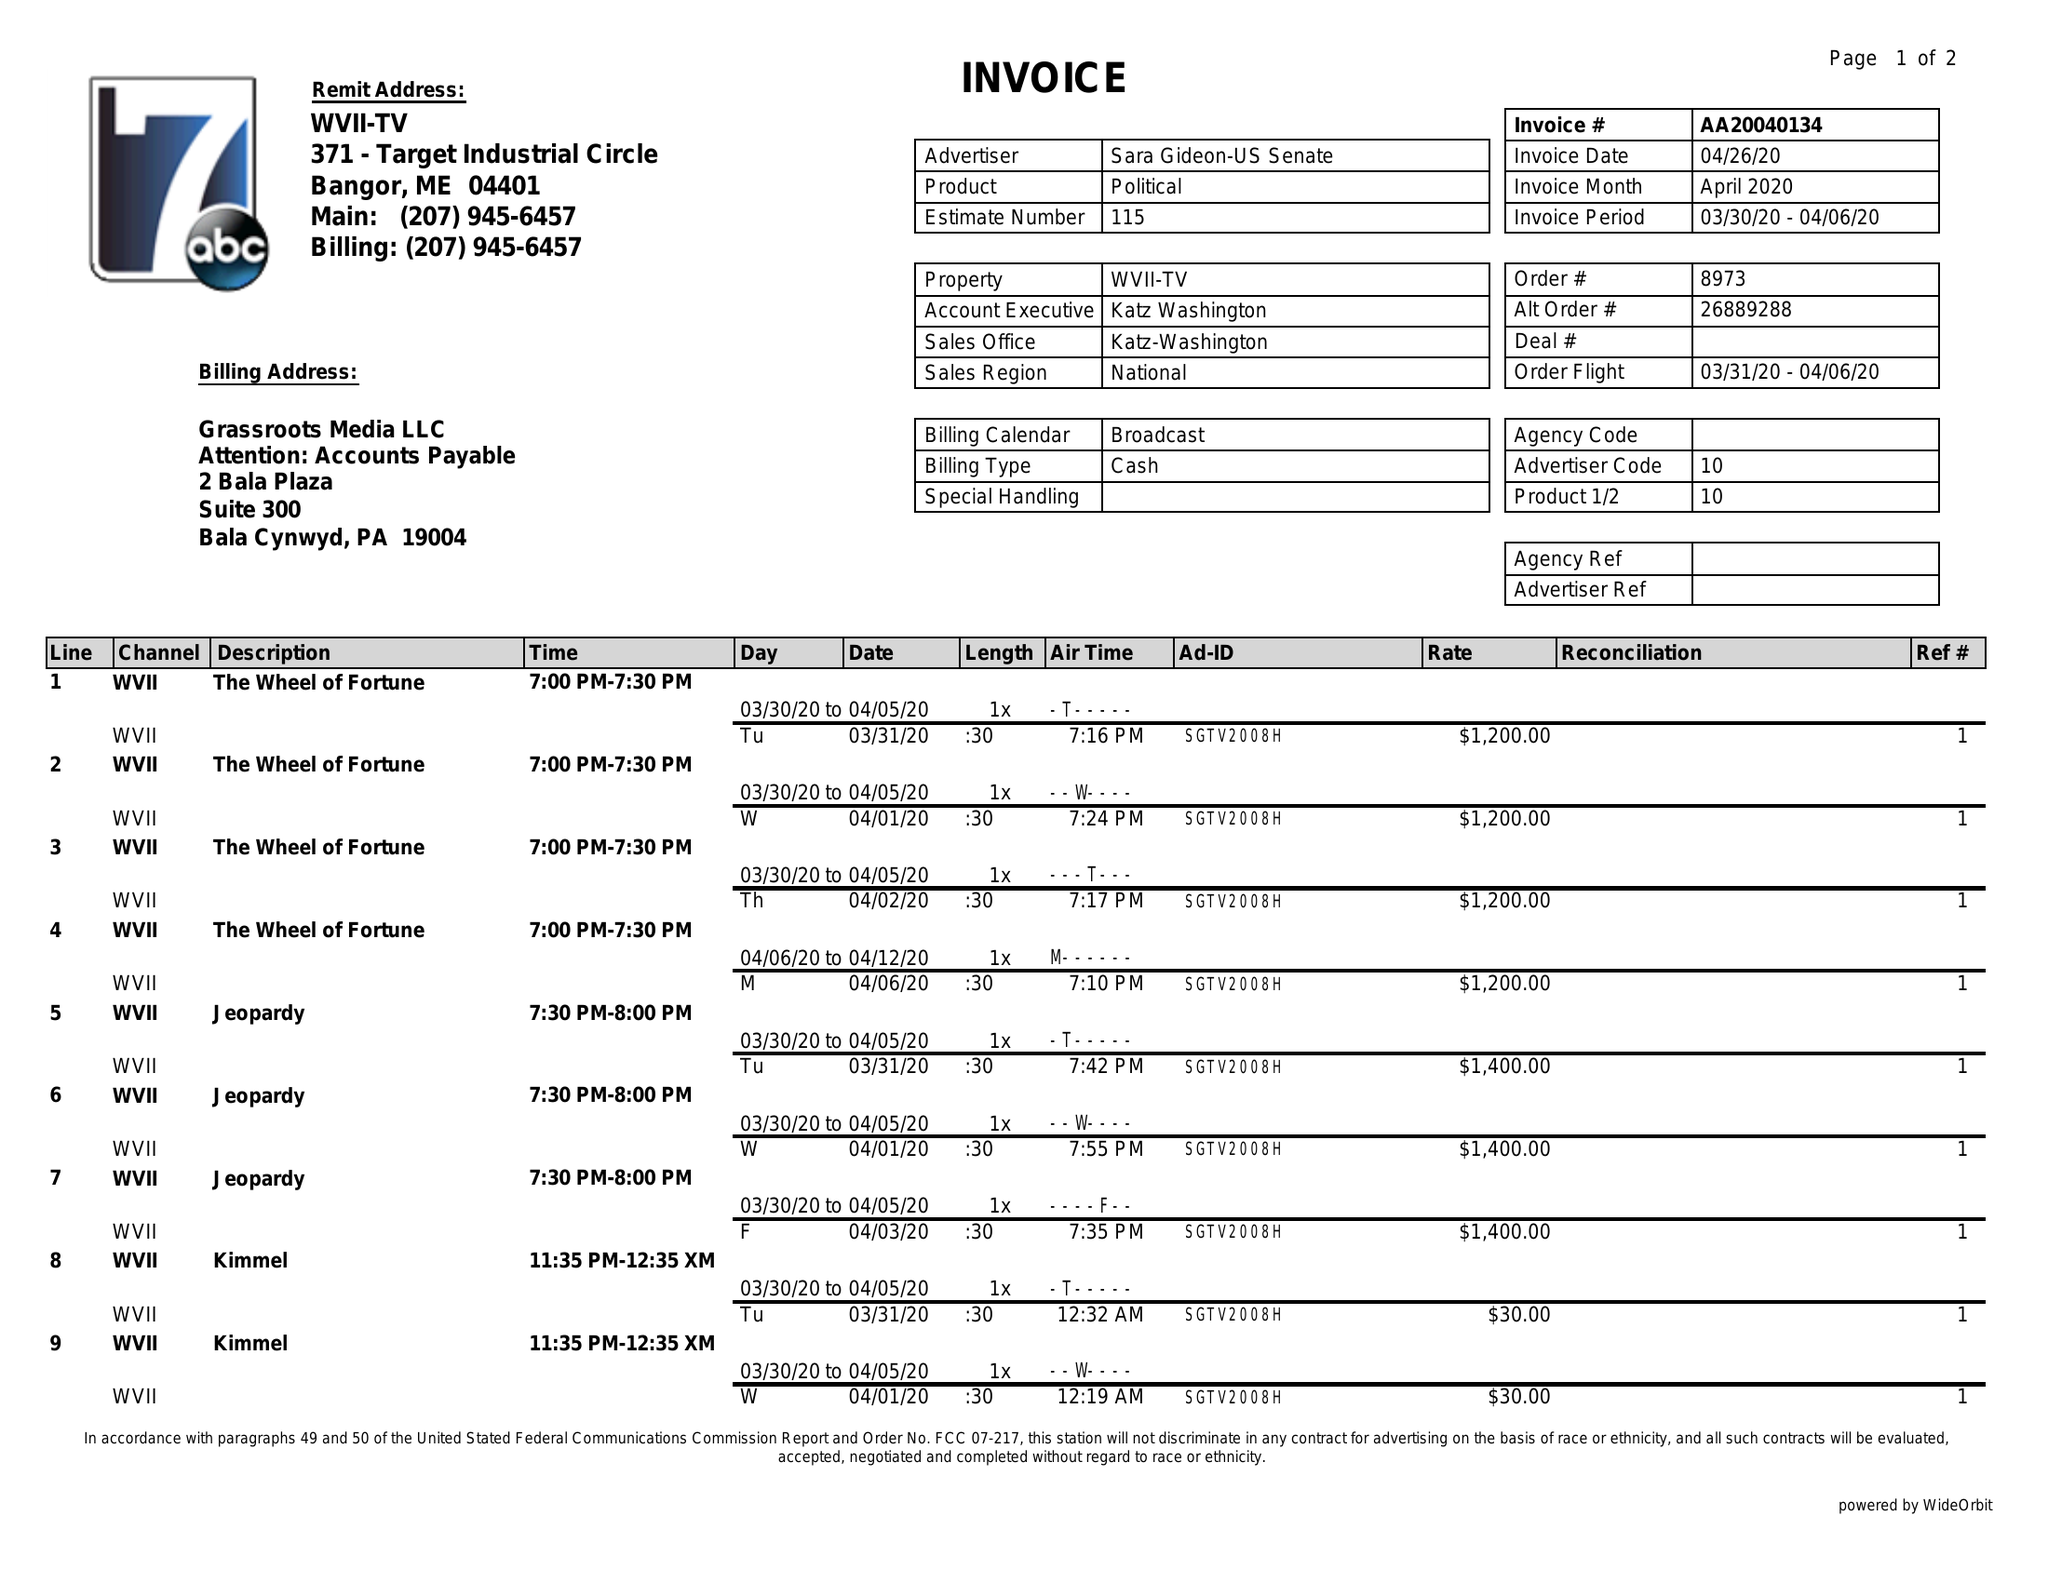What is the value for the flight_from?
Answer the question using a single word or phrase. 03/31/20 